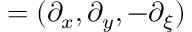<formula> <loc_0><loc_0><loc_500><loc_500>\nabla = ( \partial _ { x } , \partial _ { y } , - \partial _ { \xi } )</formula> 